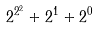Convert formula to latex. <formula><loc_0><loc_0><loc_500><loc_500>2 ^ { 2 ^ { 2 } } + 2 ^ { 1 } + 2 ^ { 0 }</formula> 